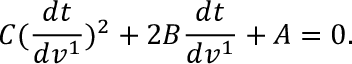<formula> <loc_0><loc_0><loc_500><loc_500>C ( \frac { d t } { d v ^ { 1 } } ) ^ { 2 } + 2 B \frac { d t } { d v ^ { 1 } } + A = 0 .</formula> 